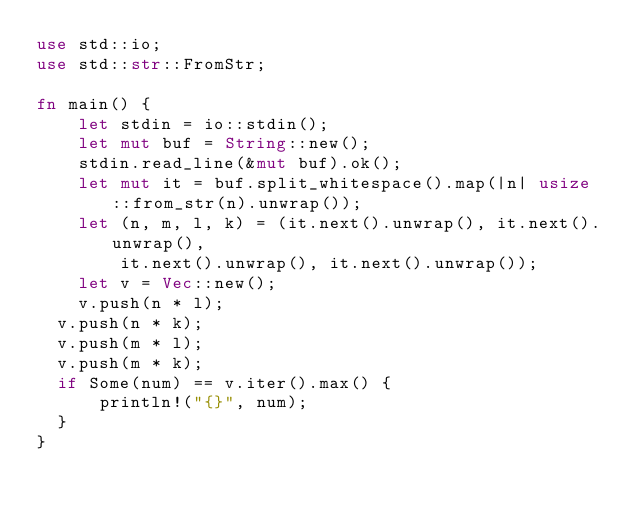Convert code to text. <code><loc_0><loc_0><loc_500><loc_500><_Rust_>use std::io;
use std::str::FromStr;
 
fn main() {
    let stdin = io::stdin();
    let mut buf = String::new();
    stdin.read_line(&mut buf).ok();
    let mut it = buf.split_whitespace().map(|n| usize::from_str(n).unwrap());
    let (n, m, l, k) = (it.next().unwrap(), it.next().unwrap(),
        it.next().unwrap(), it.next().unwrap());
    let v = Vec::new();
    v.push(n * l);
  v.push(n * k);
  v.push(m * l);
  v.push(m * k);
  if Some(num) == v.iter().max() {
    	println!("{}", num);
  }
}</code> 